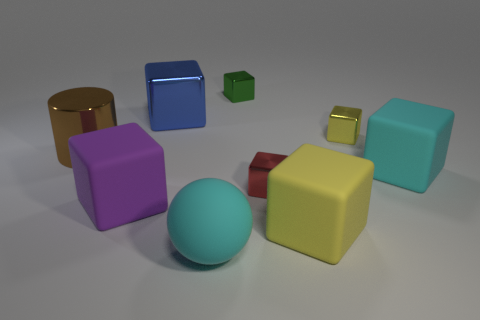The cyan object that is the same shape as the green object is what size?
Provide a succinct answer. Large. There is a rubber thing behind the tiny shiny cube that is in front of the big brown thing; what is its shape?
Make the answer very short. Cube. What number of cyan objects are large spheres or tiny blocks?
Offer a very short reply. 1. The large ball is what color?
Give a very brief answer. Cyan. Is the yellow matte cube the same size as the red thing?
Ensure brevity in your answer.  No. Is there any other thing that has the same shape as the small red metal thing?
Provide a succinct answer. Yes. Do the large blue cube and the small cube that is on the left side of the small red thing have the same material?
Ensure brevity in your answer.  Yes. There is a thing right of the tiny yellow thing; does it have the same color as the shiny cylinder?
Make the answer very short. No. How many blocks are both right of the red block and in front of the large cyan block?
Your response must be concise. 1. What number of other things are there of the same material as the large purple cube
Offer a terse response. 3. 